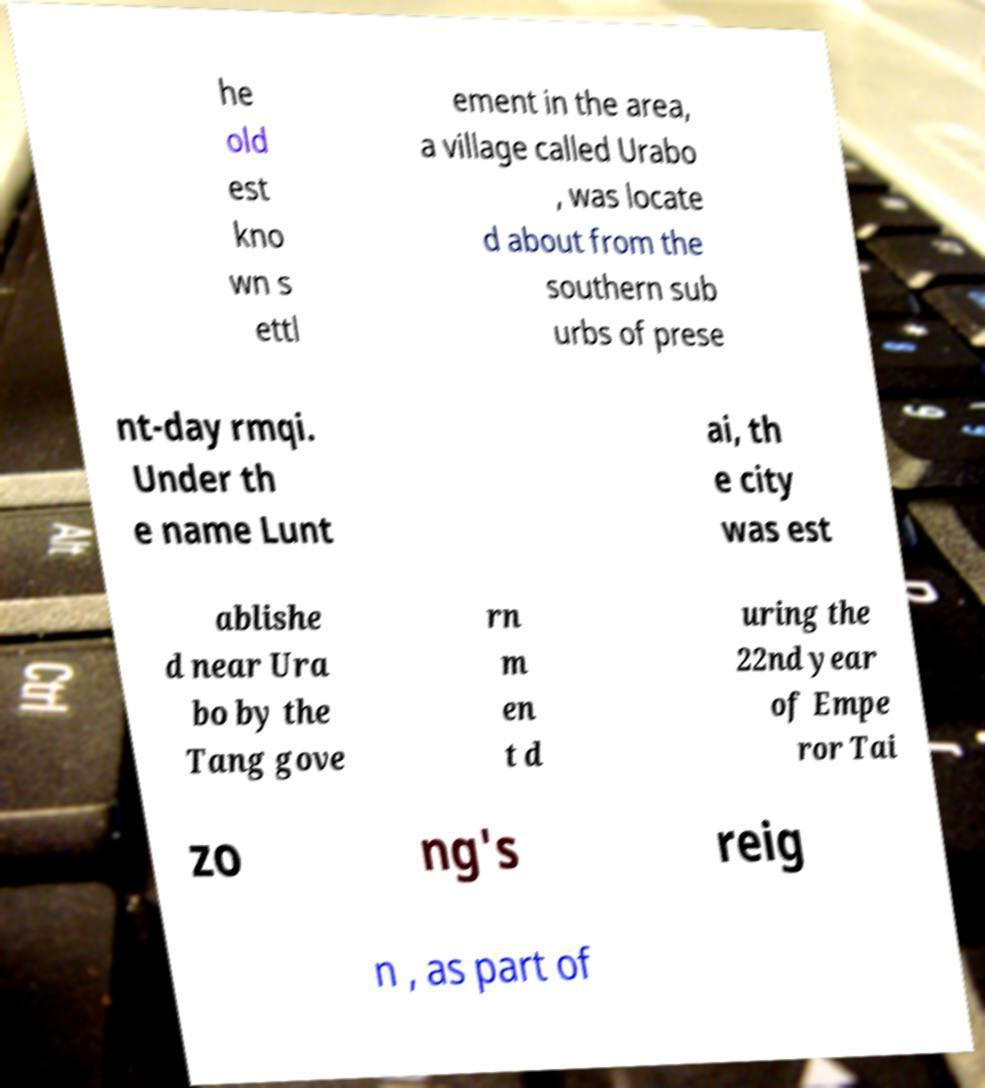Could you assist in decoding the text presented in this image and type it out clearly? he old est kno wn s ettl ement in the area, a village called Urabo , was locate d about from the southern sub urbs of prese nt-day rmqi. Under th e name Lunt ai, th e city was est ablishe d near Ura bo by the Tang gove rn m en t d uring the 22nd year of Empe ror Tai zo ng's reig n , as part of 